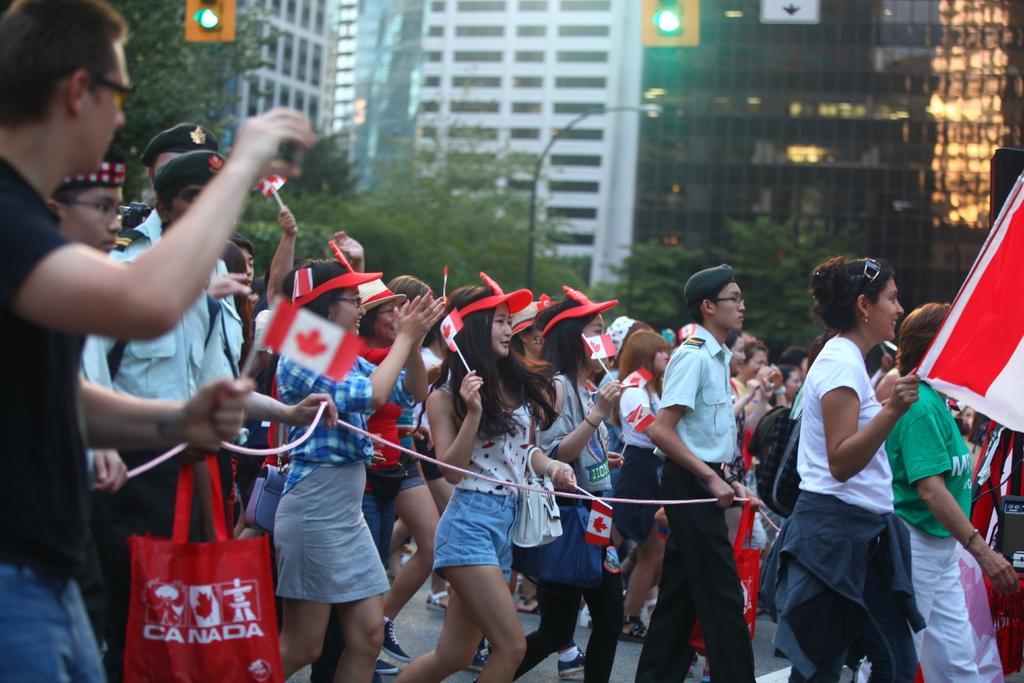Can you describe this image briefly? In this image we can see these people are holding flags and walking on the road, we can see security persons are holding ropes and this part of the image is blurred, where we can see a person wearing black color T-shirt. In the background, we can see a light pole, traffic signal poles, trees and the tower buildings. 